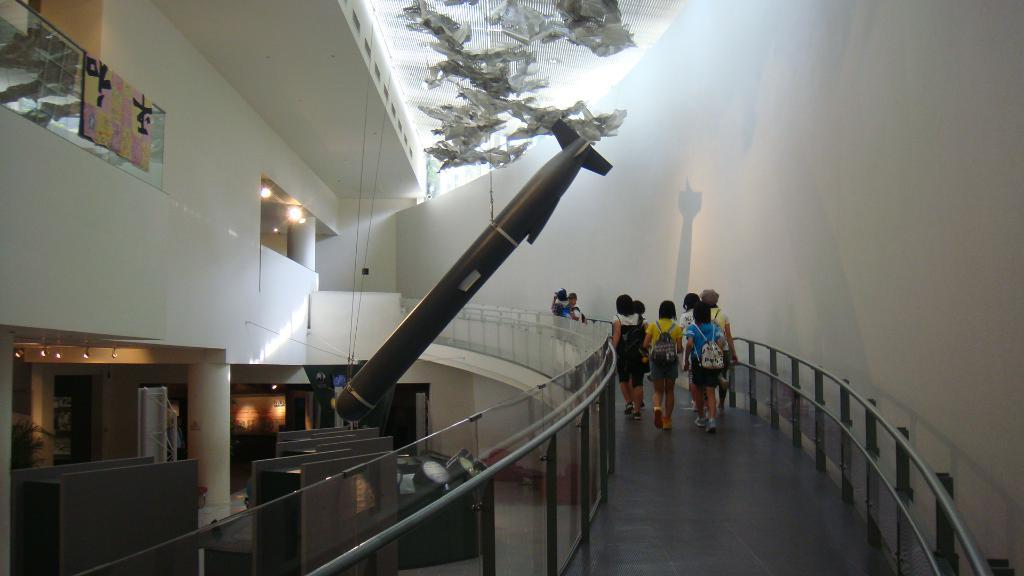What type of location is depicted in the image? The image shows an inside view of a building. What are the people in the image doing? The people in the building are walking. What architectural features can be seen in the building? Pillars and railings are visible in the building. What is used for illumination in the building? Lights are present in the building. What type of material is present in the building? There is cloth in the building. What other objects can be seen in the building? There are other objects in the building, but their specific details are not mentioned in the provided facts. What type of car is parked near the wrist in the image? There is no car or wrist present in the image; it shows an inside view of a building with people walking, pillars, railings, lights, and cloth. 